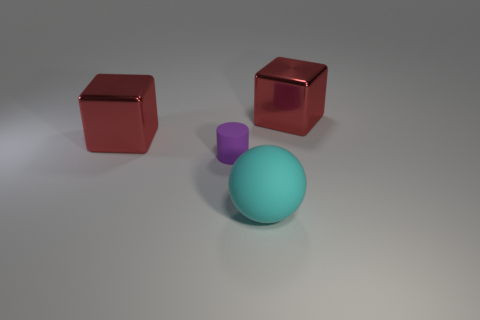Could you infer the relative sizes of the objects shown? Based on the relative scale to each object, the turquoise sphere seems to be the largest, followed by the two red cubes, with the purple cube being the smallest, although the exact dimensions cannot be determined without a reference. 